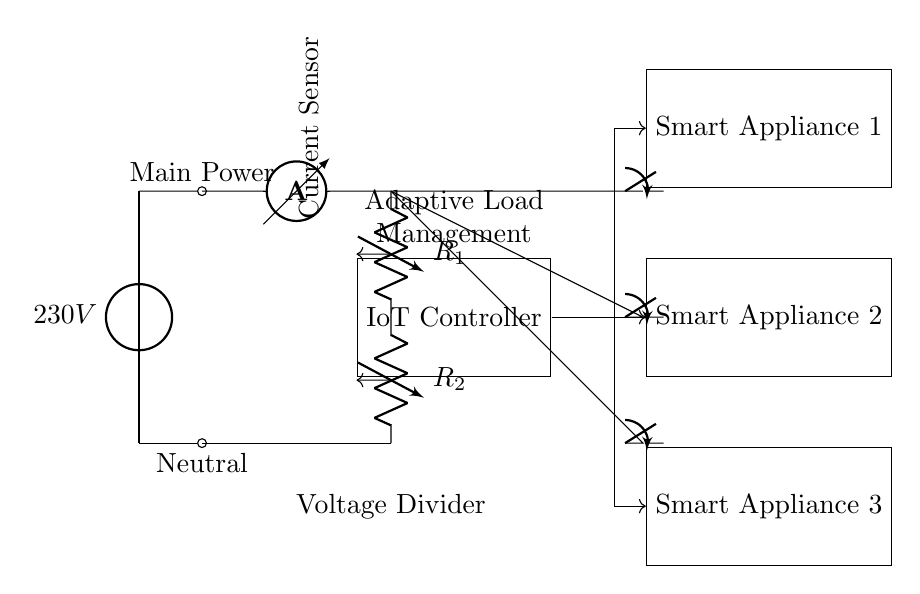What is the main voltage supply in the circuit? The circuit is supplied by a main voltage source labeled as 230V, as indicated at the top of the circuit diagram.
Answer: 230V How many smart appliances are connected to the circuit? There are three smart appliances shown in the diagram, each represented by a rectangular box labeled as Smart Appliance 1, Smart Appliance 2, and Smart Appliance 3.
Answer: Three What component measures the current in the circuit? The current sensor, labeled as ammeter, is responsible for measuring the current flowing through the circuit as depicted toward the upper section of the diagram.
Answer: Ammeter What do the resistors R1 and R2 represent in the circuit? The resistors are part of a voltage divider that reduces the voltage for the connected components, with R1 positioned above R2 as shown in the circuit layout.
Answer: Voltage divider How is the IoT controller connected to the appliances? The IoT controller connects to each smart appliance through single directional arrows pointing to each appliance, indicating the flow of controlled voltage or signals.
Answer: Through directional arrows What is the role of the adaptive load management in this circuit? The adaptive load management is displayed in a labeled box, indicating its function to manage the load efficiently across the smart appliances in conjunction with the IoT controller.
Answer: Load management What type of circuit is illustrated here? The circuit integrates adaptive load management with IoT components, specifically designed for high power appliances, indicating a system that utilizes smart technology in electricity consumption.
Answer: Adaptive load management for IoT-enabled smart appliances 